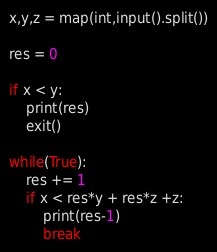Convert code to text. <code><loc_0><loc_0><loc_500><loc_500><_Python_>x,y,z = map(int,input().split())

res = 0

if x < y:
    print(res)
    exit()

while(True):
    res += 1
    if x < res*y + res*z +z:
        print(res-1)
        break


</code> 